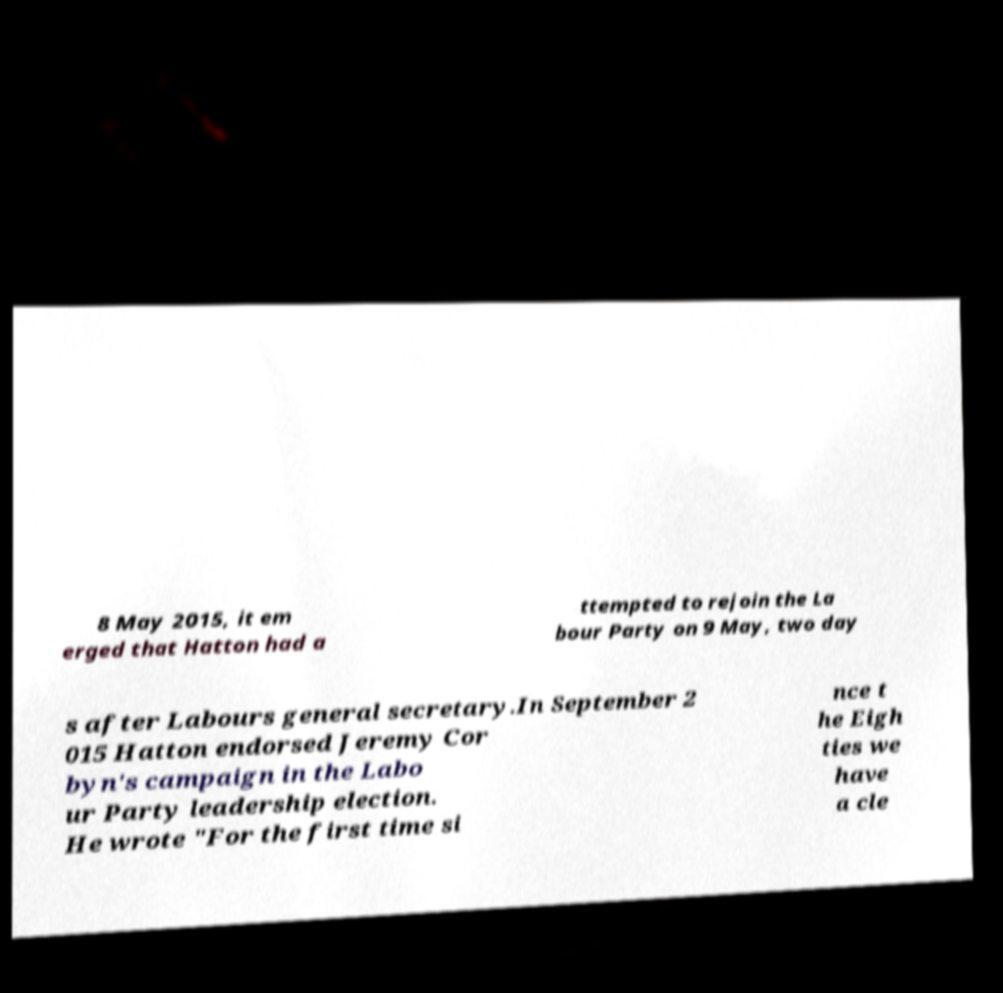Please identify and transcribe the text found in this image. 8 May 2015, it em erged that Hatton had a ttempted to rejoin the La bour Party on 9 May, two day s after Labours general secretary.In September 2 015 Hatton endorsed Jeremy Cor byn's campaign in the Labo ur Party leadership election. He wrote "For the first time si nce t he Eigh ties we have a cle 